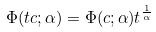<formula> <loc_0><loc_0><loc_500><loc_500>\Phi ( t c ; \alpha ) = \Phi ( c ; \alpha ) t ^ { \frac { 1 } { \alpha } }</formula> 